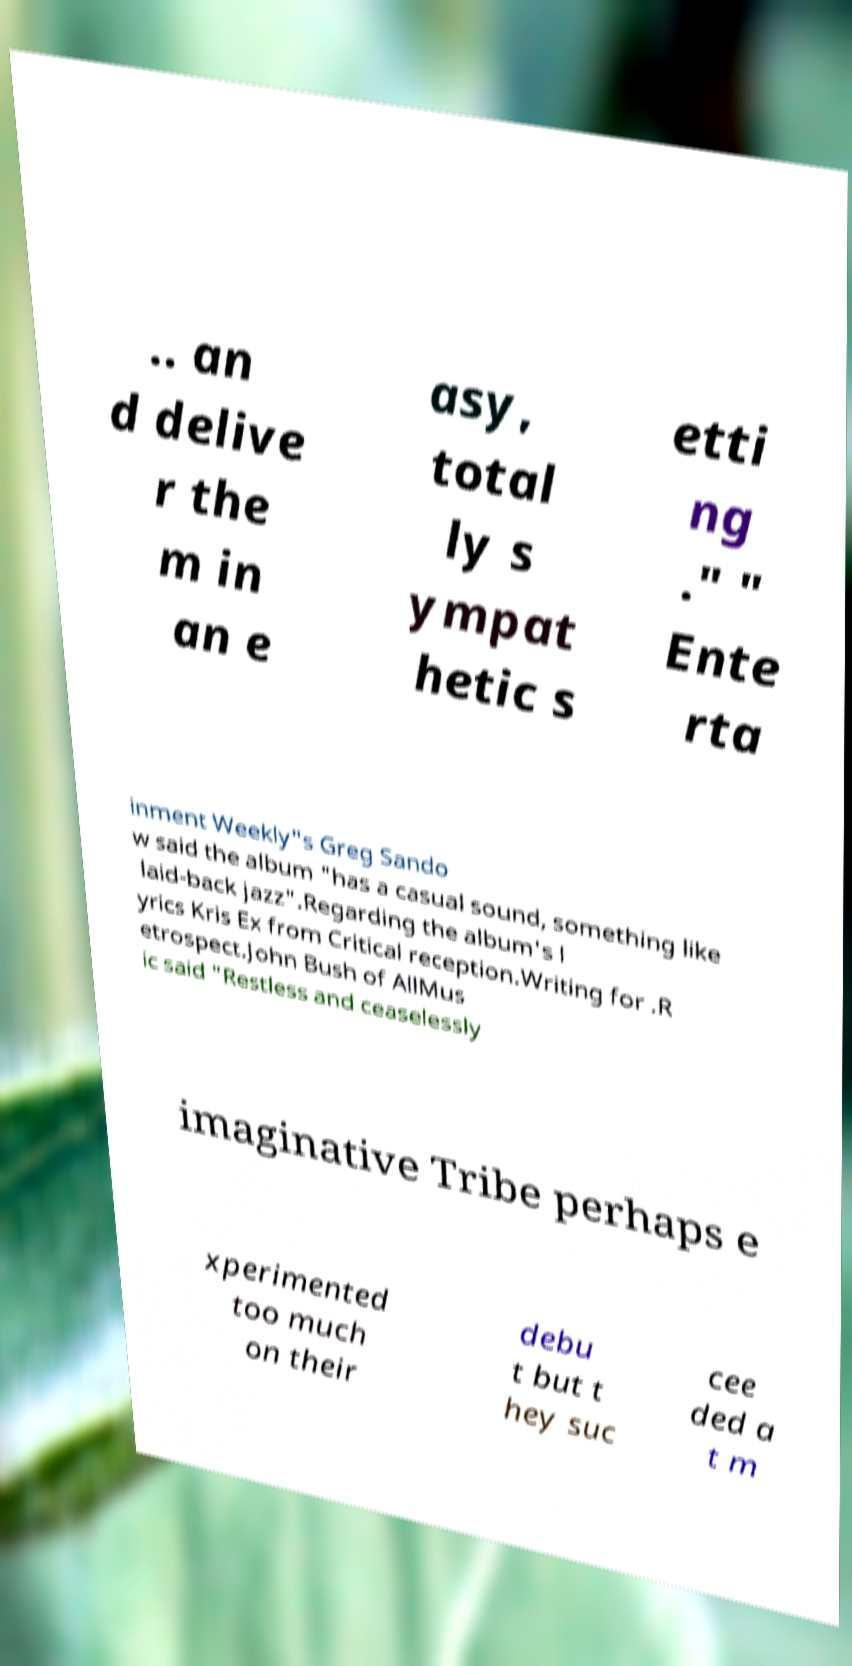I need the written content from this picture converted into text. Can you do that? .. an d delive r the m in an e asy, total ly s ympat hetic s etti ng ." " Ente rta inment Weekly"s Greg Sando w said the album "has a casual sound, something like laid-back jazz".Regarding the album's l yrics Kris Ex from Critical reception.Writing for .R etrospect.John Bush of AllMus ic said "Restless and ceaselessly imaginative Tribe perhaps e xperimented too much on their debu t but t hey suc cee ded a t m 